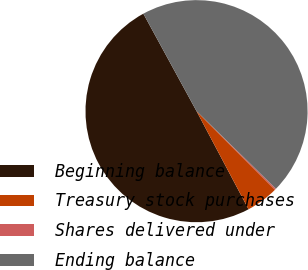<chart> <loc_0><loc_0><loc_500><loc_500><pie_chart><fcel>Beginning balance<fcel>Treasury stock purchases<fcel>Shares delivered under<fcel>Ending balance<nl><fcel>49.81%<fcel>4.73%<fcel>0.19%<fcel>45.27%<nl></chart> 